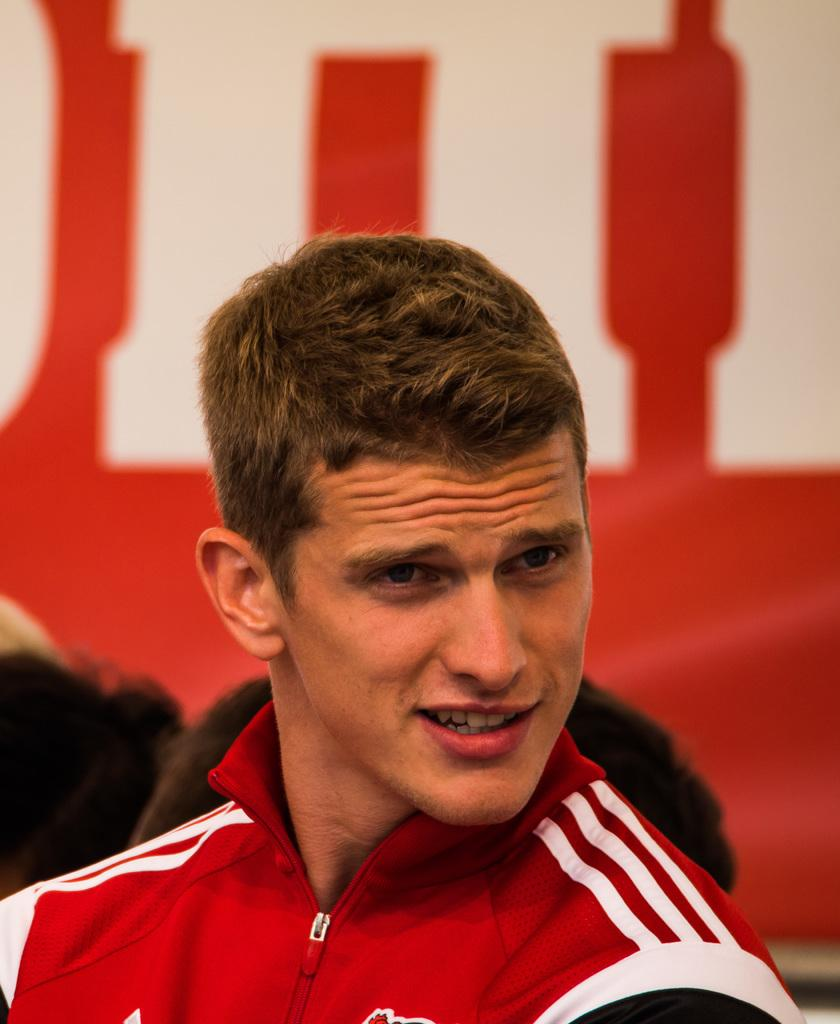Who is the main subject in the image? There is a person in the center of the image. Can you describe the surroundings of the main subject? There are persons visible in the background of the image. What else can be seen in the background of the image? There is an advertisement in the background of the image. What is the weather like in the image? The provided facts do not mention any information about the weather, so it cannot be determined from the image. 